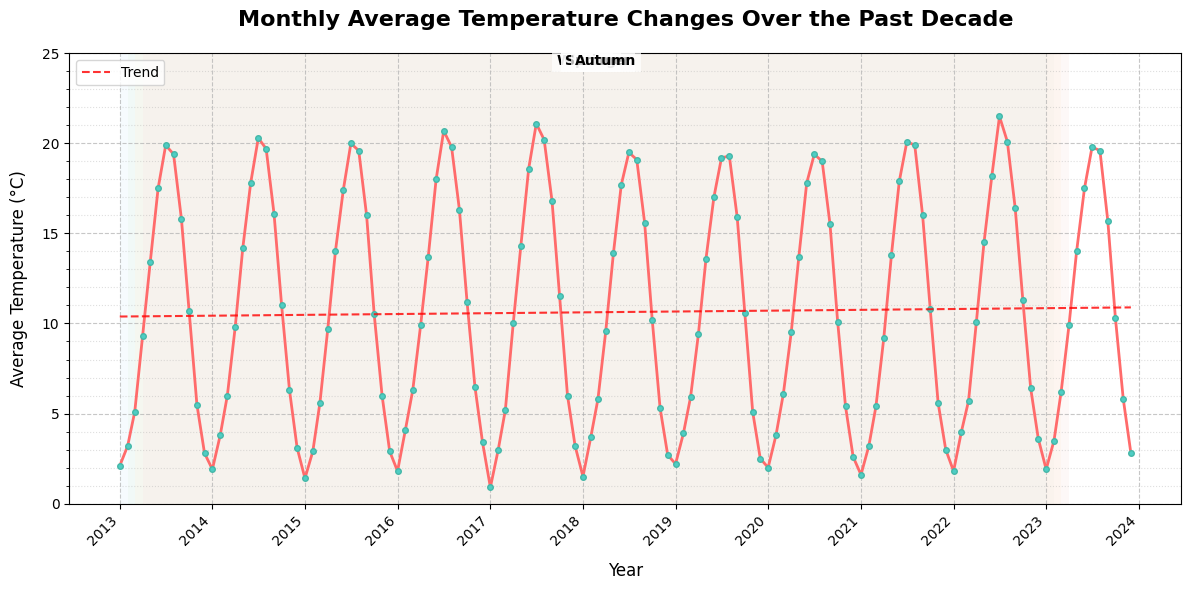What is the title of the figure? The title is typically located at the top of the plot in a larger and bold font. Here, it reads "Monthly Average Temperature Changes Over the Past Decade."
Answer: Monthly Average Temperature Changes Over the Past Decade Which year had the highest average temperature in July? Locate the points corresponding to July in each year, then check the y-axis values (temperature) to find the highest. July 2022 shows the highest temperature.
Answer: 2022 What are the average temperatures in January 2013 and January 2023, and how much did it change? First, identify the points for January 2013 and January 2023, read their values from the y-axis, and then calculate the difference. January 2013 had 2.1°C and January 2023 had 1.9°C. So, the change is 2.1 - 1.9 = 0.2°C.
Answer: 0.2°C Which season’s background color is light orange? Identify that the colored background regions represent seasons with Summer being light orange, marked in the middle months of the year.
Answer: Summer How does the average temperature in December typically compare to that in June? Identify the points for December and June in each year, compare the y-axis values, and conclude. Generally, temperatures in December are much lower than in June.
Answer: Lower in December What is the overall trend of the average temperature over the past decade? Look at the trend line added to the plot, which is a dashed red line. The trend slightly increases over time, indicating a gradual rise in average temperatures.
Answer: Gradually increasing Which had a greater increase in average temperature: March 2016 to March 2017 or March 2022 to March 2023? Identify the points for the specified dates and compute the differences. For March 2016 to March 2017, the change is 5.2 - 6.3 = -1.1°C. For March 2022 to March 2023, the change is 6.2 - 5.7 = 0.5°C. Thus, March 2022 to March 2023 shows a greater increase.
Answer: March 2022 to March 2023 What is the average temperature range observed in April over the past decade? Identify all April data points, find the minimum and maximum values, and then compute the range. April temperatures range from 9.2°C to 10.1°C, so the range is 10.1 - 9.2 = 0.9°C.
Answer: 0.9°C How many times did the average temperature in August exceed 20°C? Count all data points in August where the temperature exceeds 20°C. This only happened once in August 2017.
Answer: 1 time Which year had the least temperature variation between January and July? Calculate the difference between January and July for each year, then identify the smallest difference. For example, 2013 had 19.9 - 2.1 = 17.8°C, and so on. The year with the smallest difference is 2023 with 19.8 - 1.9 = 17.9°C.
Answer: 2023 